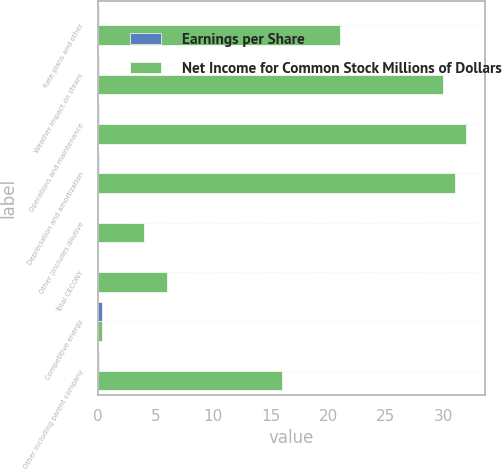Convert chart. <chart><loc_0><loc_0><loc_500><loc_500><stacked_bar_chart><ecel><fcel>Rate plans and other<fcel>Weather impact on steam<fcel>Operations and maintenance<fcel>Depreciation and amortization<fcel>Other (includes dilutive<fcel>Total CECONY<fcel>Competitive energy<fcel>Other including parent company<nl><fcel>Earnings per Share<fcel>0.07<fcel>0.1<fcel>0.11<fcel>0.11<fcel>0.01<fcel>0.02<fcel>0.34<fcel>0.06<nl><fcel>Net Income for Common Stock Millions of Dollars<fcel>21<fcel>30<fcel>32<fcel>31<fcel>4<fcel>6<fcel>0.34<fcel>16<nl></chart> 